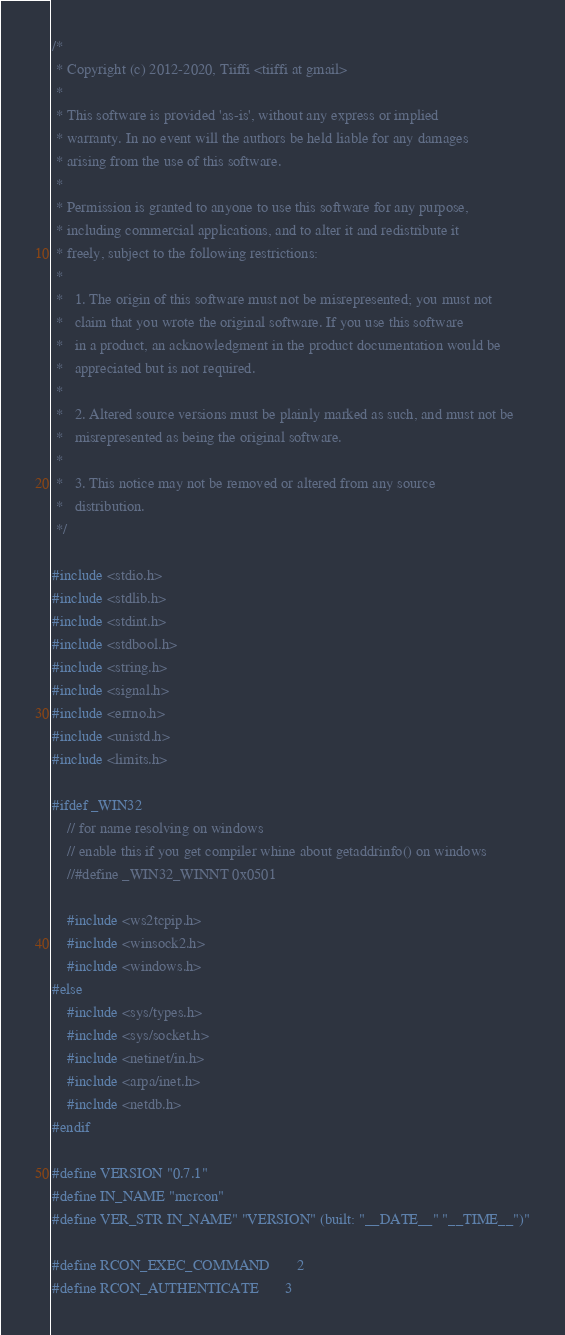<code> <loc_0><loc_0><loc_500><loc_500><_C_>/*
 * Copyright (c) 2012-2020, Tiiffi <tiiffi at gmail>
 *
 * This software is provided 'as-is', without any express or implied
 * warranty. In no event will the authors be held liable for any damages
 * arising from the use of this software.
 *
 * Permission is granted to anyone to use this software for any purpose,
 * including commercial applications, and to alter it and redistribute it
 * freely, subject to the following restrictions:
 *
 *   1. The origin of this software must not be misrepresented; you must not
 *   claim that you wrote the original software. If you use this software
 *   in a product, an acknowledgment in the product documentation would be
 *   appreciated but is not required.
 *
 *   2. Altered source versions must be plainly marked as such, and must not be
 *   misrepresented as being the original software.
 *
 *   3. This notice may not be removed or altered from any source
 *   distribution.
 */

#include <stdio.h>
#include <stdlib.h>
#include <stdint.h>
#include <stdbool.h>
#include <string.h>
#include <signal.h>
#include <errno.h>
#include <unistd.h>
#include <limits.h>

#ifdef _WIN32
    // for name resolving on windows
    // enable this if you get compiler whine about getaddrinfo() on windows
    //#define _WIN32_WINNT 0x0501

    #include <ws2tcpip.h>
    #include <winsock2.h>
    #include <windows.h>
#else
    #include <sys/types.h>
    #include <sys/socket.h>
    #include <netinet/in.h>
    #include <arpa/inet.h>
    #include <netdb.h>
#endif

#define VERSION "0.7.1"
#define IN_NAME "mcrcon"
#define VER_STR IN_NAME" "VERSION" (built: "__DATE__" "__TIME__")"

#define RCON_EXEC_COMMAND       2
#define RCON_AUTHENTICATE       3</code> 